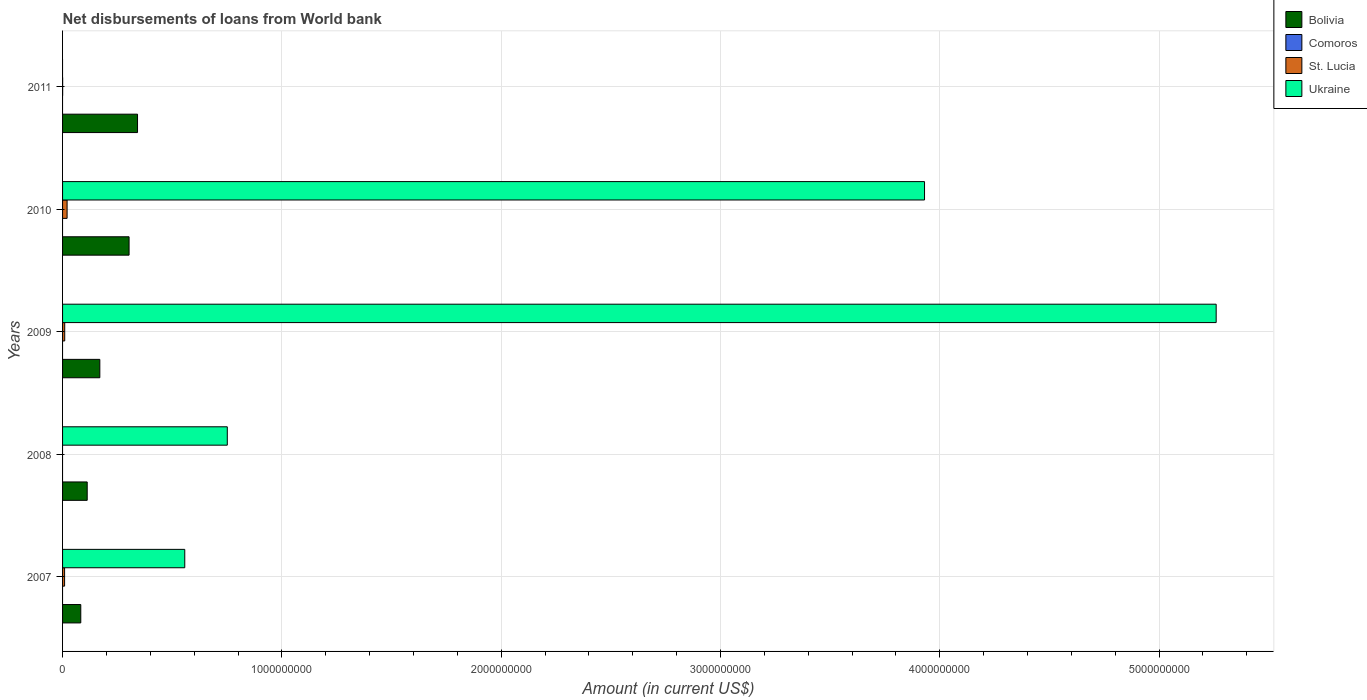How many bars are there on the 3rd tick from the bottom?
Keep it short and to the point. 3. What is the label of the 1st group of bars from the top?
Provide a succinct answer. 2011. What is the amount of loan disbursed from World Bank in Bolivia in 2010?
Offer a terse response. 3.03e+08. Across all years, what is the maximum amount of loan disbursed from World Bank in Ukraine?
Your response must be concise. 5.26e+09. In which year was the amount of loan disbursed from World Bank in St. Lucia maximum?
Offer a very short reply. 2010. What is the total amount of loan disbursed from World Bank in St. Lucia in the graph?
Make the answer very short. 4.01e+07. What is the difference between the amount of loan disbursed from World Bank in Bolivia in 2009 and that in 2010?
Your answer should be compact. -1.33e+08. What is the difference between the amount of loan disbursed from World Bank in St. Lucia in 2011 and the amount of loan disbursed from World Bank in Comoros in 2007?
Give a very brief answer. 3.63e+05. What is the average amount of loan disbursed from World Bank in Ukraine per year?
Make the answer very short. 2.10e+09. In the year 2008, what is the difference between the amount of loan disbursed from World Bank in Ukraine and amount of loan disbursed from World Bank in Bolivia?
Keep it short and to the point. 6.39e+08. In how many years, is the amount of loan disbursed from World Bank in Ukraine greater than 200000000 US$?
Offer a terse response. 4. What is the ratio of the amount of loan disbursed from World Bank in Ukraine in 2007 to that in 2008?
Your answer should be compact. 0.74. Is the amount of loan disbursed from World Bank in Bolivia in 2009 less than that in 2010?
Provide a succinct answer. Yes. Is the difference between the amount of loan disbursed from World Bank in Ukraine in 2007 and 2010 greater than the difference between the amount of loan disbursed from World Bank in Bolivia in 2007 and 2010?
Your answer should be very brief. No. What is the difference between the highest and the second highest amount of loan disbursed from World Bank in St. Lucia?
Make the answer very short. 1.08e+07. What is the difference between the highest and the lowest amount of loan disbursed from World Bank in Ukraine?
Provide a succinct answer. 5.26e+09. Is the sum of the amount of loan disbursed from World Bank in St. Lucia in 2010 and 2011 greater than the maximum amount of loan disbursed from World Bank in Bolivia across all years?
Keep it short and to the point. No. Is it the case that in every year, the sum of the amount of loan disbursed from World Bank in Ukraine and amount of loan disbursed from World Bank in St. Lucia is greater than the sum of amount of loan disbursed from World Bank in Comoros and amount of loan disbursed from World Bank in Bolivia?
Give a very brief answer. No. Is it the case that in every year, the sum of the amount of loan disbursed from World Bank in St. Lucia and amount of loan disbursed from World Bank in Ukraine is greater than the amount of loan disbursed from World Bank in Bolivia?
Your answer should be compact. No. How many bars are there?
Provide a short and direct response. 13. How many years are there in the graph?
Give a very brief answer. 5. What is the difference between two consecutive major ticks on the X-axis?
Make the answer very short. 1.00e+09. Does the graph contain any zero values?
Offer a terse response. Yes. What is the title of the graph?
Offer a terse response. Net disbursements of loans from World bank. What is the label or title of the X-axis?
Provide a succinct answer. Amount (in current US$). What is the label or title of the Y-axis?
Ensure brevity in your answer.  Years. What is the Amount (in current US$) in Bolivia in 2007?
Make the answer very short. 8.31e+07. What is the Amount (in current US$) of St. Lucia in 2007?
Keep it short and to the point. 9.22e+06. What is the Amount (in current US$) in Ukraine in 2007?
Offer a terse response. 5.57e+08. What is the Amount (in current US$) of Bolivia in 2008?
Your answer should be compact. 1.12e+08. What is the Amount (in current US$) in Comoros in 2008?
Provide a short and direct response. 0. What is the Amount (in current US$) of St. Lucia in 2008?
Keep it short and to the point. 0. What is the Amount (in current US$) in Ukraine in 2008?
Offer a terse response. 7.51e+08. What is the Amount (in current US$) of Bolivia in 2009?
Your response must be concise. 1.70e+08. What is the Amount (in current US$) of Comoros in 2009?
Give a very brief answer. 0. What is the Amount (in current US$) of St. Lucia in 2009?
Your answer should be compact. 9.85e+06. What is the Amount (in current US$) of Ukraine in 2009?
Give a very brief answer. 5.26e+09. What is the Amount (in current US$) in Bolivia in 2010?
Keep it short and to the point. 3.03e+08. What is the Amount (in current US$) of St. Lucia in 2010?
Offer a very short reply. 2.07e+07. What is the Amount (in current US$) of Ukraine in 2010?
Provide a succinct answer. 3.93e+09. What is the Amount (in current US$) of Bolivia in 2011?
Provide a short and direct response. 3.42e+08. What is the Amount (in current US$) of St. Lucia in 2011?
Your response must be concise. 3.63e+05. Across all years, what is the maximum Amount (in current US$) in Bolivia?
Provide a succinct answer. 3.42e+08. Across all years, what is the maximum Amount (in current US$) in St. Lucia?
Offer a terse response. 2.07e+07. Across all years, what is the maximum Amount (in current US$) of Ukraine?
Give a very brief answer. 5.26e+09. Across all years, what is the minimum Amount (in current US$) of Bolivia?
Ensure brevity in your answer.  8.31e+07. What is the total Amount (in current US$) in Bolivia in the graph?
Make the answer very short. 1.01e+09. What is the total Amount (in current US$) in St. Lucia in the graph?
Ensure brevity in your answer.  4.01e+07. What is the total Amount (in current US$) of Ukraine in the graph?
Give a very brief answer. 1.05e+1. What is the difference between the Amount (in current US$) in Bolivia in 2007 and that in 2008?
Ensure brevity in your answer.  -2.92e+07. What is the difference between the Amount (in current US$) in Ukraine in 2007 and that in 2008?
Your answer should be very brief. -1.94e+08. What is the difference between the Amount (in current US$) of Bolivia in 2007 and that in 2009?
Your answer should be compact. -8.69e+07. What is the difference between the Amount (in current US$) in St. Lucia in 2007 and that in 2009?
Provide a short and direct response. -6.34e+05. What is the difference between the Amount (in current US$) of Ukraine in 2007 and that in 2009?
Make the answer very short. -4.70e+09. What is the difference between the Amount (in current US$) of Bolivia in 2007 and that in 2010?
Ensure brevity in your answer.  -2.20e+08. What is the difference between the Amount (in current US$) of St. Lucia in 2007 and that in 2010?
Provide a succinct answer. -1.15e+07. What is the difference between the Amount (in current US$) in Ukraine in 2007 and that in 2010?
Your response must be concise. -3.37e+09. What is the difference between the Amount (in current US$) in Bolivia in 2007 and that in 2011?
Keep it short and to the point. -2.59e+08. What is the difference between the Amount (in current US$) in St. Lucia in 2007 and that in 2011?
Make the answer very short. 8.85e+06. What is the difference between the Amount (in current US$) of Bolivia in 2008 and that in 2009?
Give a very brief answer. -5.76e+07. What is the difference between the Amount (in current US$) in Ukraine in 2008 and that in 2009?
Ensure brevity in your answer.  -4.51e+09. What is the difference between the Amount (in current US$) in Bolivia in 2008 and that in 2010?
Your response must be concise. -1.91e+08. What is the difference between the Amount (in current US$) in Ukraine in 2008 and that in 2010?
Offer a terse response. -3.18e+09. What is the difference between the Amount (in current US$) of Bolivia in 2008 and that in 2011?
Provide a succinct answer. -2.29e+08. What is the difference between the Amount (in current US$) of Bolivia in 2009 and that in 2010?
Offer a very short reply. -1.33e+08. What is the difference between the Amount (in current US$) in St. Lucia in 2009 and that in 2010?
Your answer should be very brief. -1.08e+07. What is the difference between the Amount (in current US$) of Ukraine in 2009 and that in 2010?
Your response must be concise. 1.33e+09. What is the difference between the Amount (in current US$) in Bolivia in 2009 and that in 2011?
Ensure brevity in your answer.  -1.72e+08. What is the difference between the Amount (in current US$) in St. Lucia in 2009 and that in 2011?
Ensure brevity in your answer.  9.49e+06. What is the difference between the Amount (in current US$) of Bolivia in 2010 and that in 2011?
Your response must be concise. -3.85e+07. What is the difference between the Amount (in current US$) in St. Lucia in 2010 and that in 2011?
Give a very brief answer. 2.03e+07. What is the difference between the Amount (in current US$) in Bolivia in 2007 and the Amount (in current US$) in Ukraine in 2008?
Keep it short and to the point. -6.68e+08. What is the difference between the Amount (in current US$) in St. Lucia in 2007 and the Amount (in current US$) in Ukraine in 2008?
Offer a very short reply. -7.42e+08. What is the difference between the Amount (in current US$) of Bolivia in 2007 and the Amount (in current US$) of St. Lucia in 2009?
Offer a terse response. 7.32e+07. What is the difference between the Amount (in current US$) in Bolivia in 2007 and the Amount (in current US$) in Ukraine in 2009?
Keep it short and to the point. -5.18e+09. What is the difference between the Amount (in current US$) of St. Lucia in 2007 and the Amount (in current US$) of Ukraine in 2009?
Your answer should be very brief. -5.25e+09. What is the difference between the Amount (in current US$) in Bolivia in 2007 and the Amount (in current US$) in St. Lucia in 2010?
Your answer should be compact. 6.24e+07. What is the difference between the Amount (in current US$) in Bolivia in 2007 and the Amount (in current US$) in Ukraine in 2010?
Keep it short and to the point. -3.85e+09. What is the difference between the Amount (in current US$) in St. Lucia in 2007 and the Amount (in current US$) in Ukraine in 2010?
Your answer should be compact. -3.92e+09. What is the difference between the Amount (in current US$) of Bolivia in 2007 and the Amount (in current US$) of St. Lucia in 2011?
Keep it short and to the point. 8.27e+07. What is the difference between the Amount (in current US$) in Bolivia in 2008 and the Amount (in current US$) in St. Lucia in 2009?
Provide a short and direct response. 1.02e+08. What is the difference between the Amount (in current US$) in Bolivia in 2008 and the Amount (in current US$) in Ukraine in 2009?
Your answer should be compact. -5.15e+09. What is the difference between the Amount (in current US$) of Bolivia in 2008 and the Amount (in current US$) of St. Lucia in 2010?
Provide a succinct answer. 9.17e+07. What is the difference between the Amount (in current US$) of Bolivia in 2008 and the Amount (in current US$) of Ukraine in 2010?
Provide a succinct answer. -3.82e+09. What is the difference between the Amount (in current US$) in Bolivia in 2008 and the Amount (in current US$) in St. Lucia in 2011?
Your answer should be compact. 1.12e+08. What is the difference between the Amount (in current US$) in Bolivia in 2009 and the Amount (in current US$) in St. Lucia in 2010?
Ensure brevity in your answer.  1.49e+08. What is the difference between the Amount (in current US$) of Bolivia in 2009 and the Amount (in current US$) of Ukraine in 2010?
Your response must be concise. -3.76e+09. What is the difference between the Amount (in current US$) in St. Lucia in 2009 and the Amount (in current US$) in Ukraine in 2010?
Give a very brief answer. -3.92e+09. What is the difference between the Amount (in current US$) in Bolivia in 2009 and the Amount (in current US$) in St. Lucia in 2011?
Offer a very short reply. 1.70e+08. What is the difference between the Amount (in current US$) of Bolivia in 2010 and the Amount (in current US$) of St. Lucia in 2011?
Your answer should be compact. 3.03e+08. What is the average Amount (in current US$) in Bolivia per year?
Offer a terse response. 2.02e+08. What is the average Amount (in current US$) in St. Lucia per year?
Give a very brief answer. 8.02e+06. What is the average Amount (in current US$) in Ukraine per year?
Your response must be concise. 2.10e+09. In the year 2007, what is the difference between the Amount (in current US$) in Bolivia and Amount (in current US$) in St. Lucia?
Provide a succinct answer. 7.39e+07. In the year 2007, what is the difference between the Amount (in current US$) of Bolivia and Amount (in current US$) of Ukraine?
Your answer should be very brief. -4.74e+08. In the year 2007, what is the difference between the Amount (in current US$) of St. Lucia and Amount (in current US$) of Ukraine?
Ensure brevity in your answer.  -5.48e+08. In the year 2008, what is the difference between the Amount (in current US$) of Bolivia and Amount (in current US$) of Ukraine?
Provide a short and direct response. -6.39e+08. In the year 2009, what is the difference between the Amount (in current US$) in Bolivia and Amount (in current US$) in St. Lucia?
Offer a terse response. 1.60e+08. In the year 2009, what is the difference between the Amount (in current US$) in Bolivia and Amount (in current US$) in Ukraine?
Give a very brief answer. -5.09e+09. In the year 2009, what is the difference between the Amount (in current US$) of St. Lucia and Amount (in current US$) of Ukraine?
Offer a terse response. -5.25e+09. In the year 2010, what is the difference between the Amount (in current US$) of Bolivia and Amount (in current US$) of St. Lucia?
Your response must be concise. 2.83e+08. In the year 2010, what is the difference between the Amount (in current US$) of Bolivia and Amount (in current US$) of Ukraine?
Keep it short and to the point. -3.63e+09. In the year 2010, what is the difference between the Amount (in current US$) in St. Lucia and Amount (in current US$) in Ukraine?
Offer a terse response. -3.91e+09. In the year 2011, what is the difference between the Amount (in current US$) of Bolivia and Amount (in current US$) of St. Lucia?
Your response must be concise. 3.41e+08. What is the ratio of the Amount (in current US$) of Bolivia in 2007 to that in 2008?
Give a very brief answer. 0.74. What is the ratio of the Amount (in current US$) of Ukraine in 2007 to that in 2008?
Keep it short and to the point. 0.74. What is the ratio of the Amount (in current US$) of Bolivia in 2007 to that in 2009?
Make the answer very short. 0.49. What is the ratio of the Amount (in current US$) in St. Lucia in 2007 to that in 2009?
Provide a succinct answer. 0.94. What is the ratio of the Amount (in current US$) in Ukraine in 2007 to that in 2009?
Keep it short and to the point. 0.11. What is the ratio of the Amount (in current US$) in Bolivia in 2007 to that in 2010?
Make the answer very short. 0.27. What is the ratio of the Amount (in current US$) in St. Lucia in 2007 to that in 2010?
Make the answer very short. 0.45. What is the ratio of the Amount (in current US$) in Ukraine in 2007 to that in 2010?
Ensure brevity in your answer.  0.14. What is the ratio of the Amount (in current US$) in Bolivia in 2007 to that in 2011?
Make the answer very short. 0.24. What is the ratio of the Amount (in current US$) of St. Lucia in 2007 to that in 2011?
Provide a short and direct response. 25.39. What is the ratio of the Amount (in current US$) in Bolivia in 2008 to that in 2009?
Offer a very short reply. 0.66. What is the ratio of the Amount (in current US$) of Ukraine in 2008 to that in 2009?
Your answer should be very brief. 0.14. What is the ratio of the Amount (in current US$) in Bolivia in 2008 to that in 2010?
Provide a short and direct response. 0.37. What is the ratio of the Amount (in current US$) of Ukraine in 2008 to that in 2010?
Offer a very short reply. 0.19. What is the ratio of the Amount (in current US$) in Bolivia in 2008 to that in 2011?
Ensure brevity in your answer.  0.33. What is the ratio of the Amount (in current US$) in Bolivia in 2009 to that in 2010?
Offer a very short reply. 0.56. What is the ratio of the Amount (in current US$) of St. Lucia in 2009 to that in 2010?
Offer a very short reply. 0.48. What is the ratio of the Amount (in current US$) in Ukraine in 2009 to that in 2010?
Keep it short and to the point. 1.34. What is the ratio of the Amount (in current US$) of Bolivia in 2009 to that in 2011?
Offer a terse response. 0.5. What is the ratio of the Amount (in current US$) in St. Lucia in 2009 to that in 2011?
Make the answer very short. 27.13. What is the ratio of the Amount (in current US$) of Bolivia in 2010 to that in 2011?
Your answer should be very brief. 0.89. What is the ratio of the Amount (in current US$) of St. Lucia in 2010 to that in 2011?
Offer a very short reply. 56.97. What is the difference between the highest and the second highest Amount (in current US$) in Bolivia?
Give a very brief answer. 3.85e+07. What is the difference between the highest and the second highest Amount (in current US$) of St. Lucia?
Offer a terse response. 1.08e+07. What is the difference between the highest and the second highest Amount (in current US$) in Ukraine?
Provide a short and direct response. 1.33e+09. What is the difference between the highest and the lowest Amount (in current US$) in Bolivia?
Keep it short and to the point. 2.59e+08. What is the difference between the highest and the lowest Amount (in current US$) in St. Lucia?
Your answer should be compact. 2.07e+07. What is the difference between the highest and the lowest Amount (in current US$) in Ukraine?
Offer a terse response. 5.26e+09. 